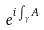Convert formula to latex. <formula><loc_0><loc_0><loc_500><loc_500>e ^ { i \int _ { \gamma } A }</formula> 